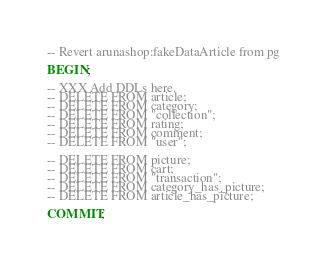Convert code to text. <code><loc_0><loc_0><loc_500><loc_500><_SQL_>-- Revert arunashop:fakeDataArticle from pg

BEGIN;

-- XXX Add DDLs here.
-- DELETE FROM article;
-- DELETE FROM category;
-- DELETE FROM "collection";
-- DELETE FROM rating;
-- DELETE FROM comment;
-- DELETE FROM "user";

-- DELETE FROM picture;
-- DELETE FROM cart;
-- DELETE FROM "transaction";
-- DELETE FROM category_has_picture;
-- DELETE FROM article_has_picture;

COMMIT;
</code> 